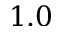Convert formula to latex. <formula><loc_0><loc_0><loc_500><loc_500>1 . 0</formula> 